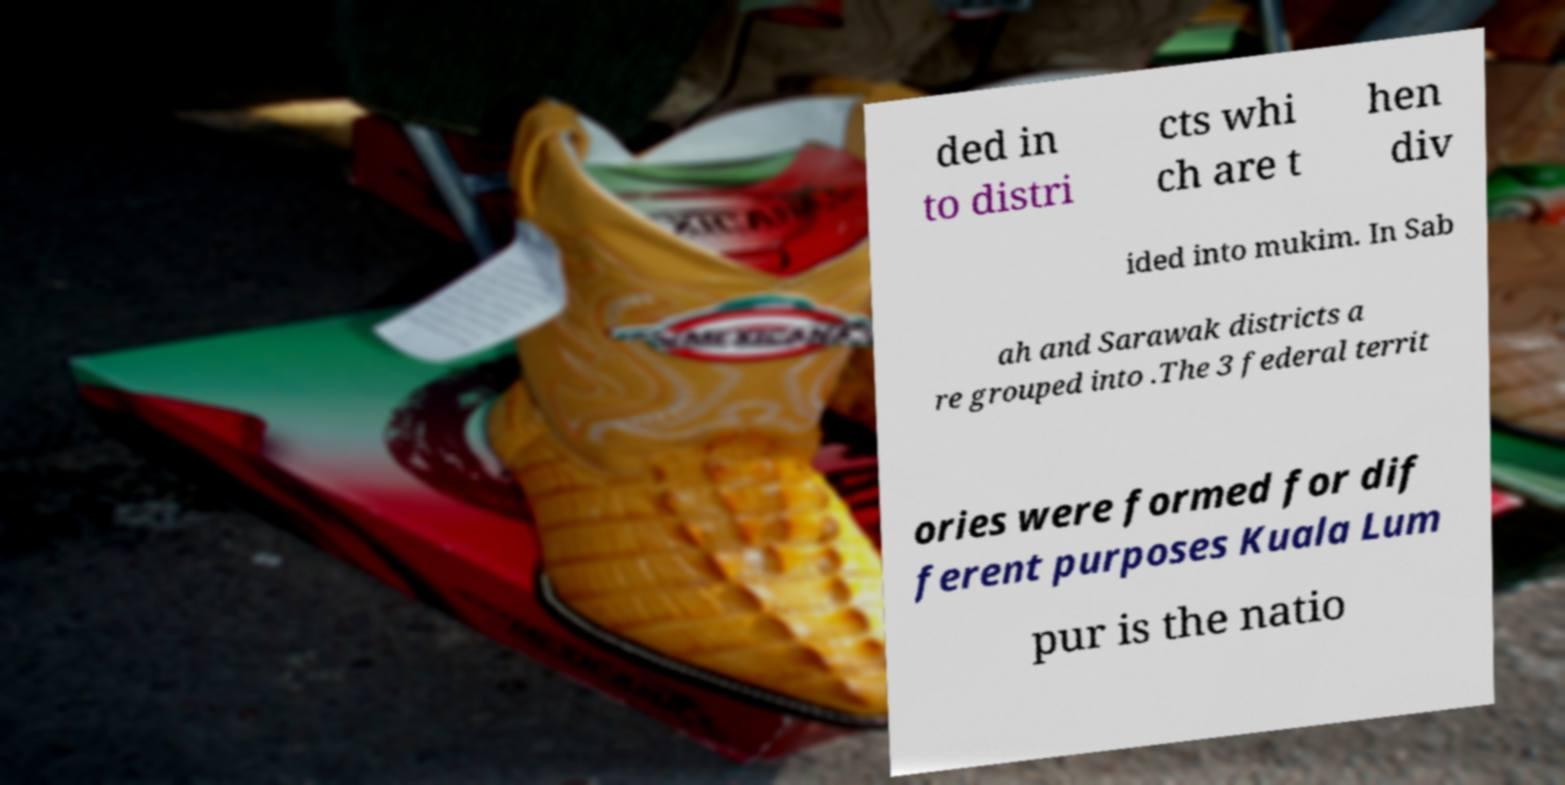There's text embedded in this image that I need extracted. Can you transcribe it verbatim? ded in to distri cts whi ch are t hen div ided into mukim. In Sab ah and Sarawak districts a re grouped into .The 3 federal territ ories were formed for dif ferent purposes Kuala Lum pur is the natio 